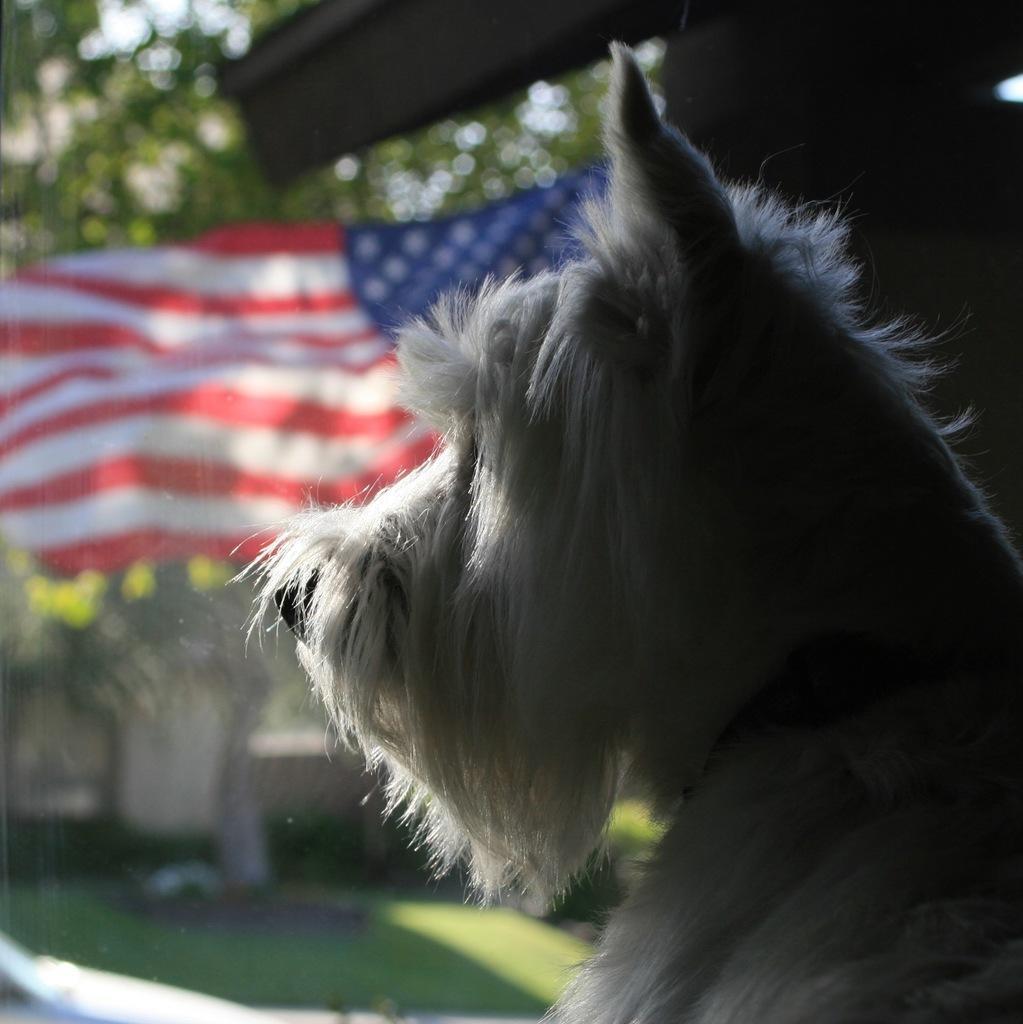Could you give a brief overview of what you see in this image? In this picture I can see a dog and a flag, and there is blur background. 